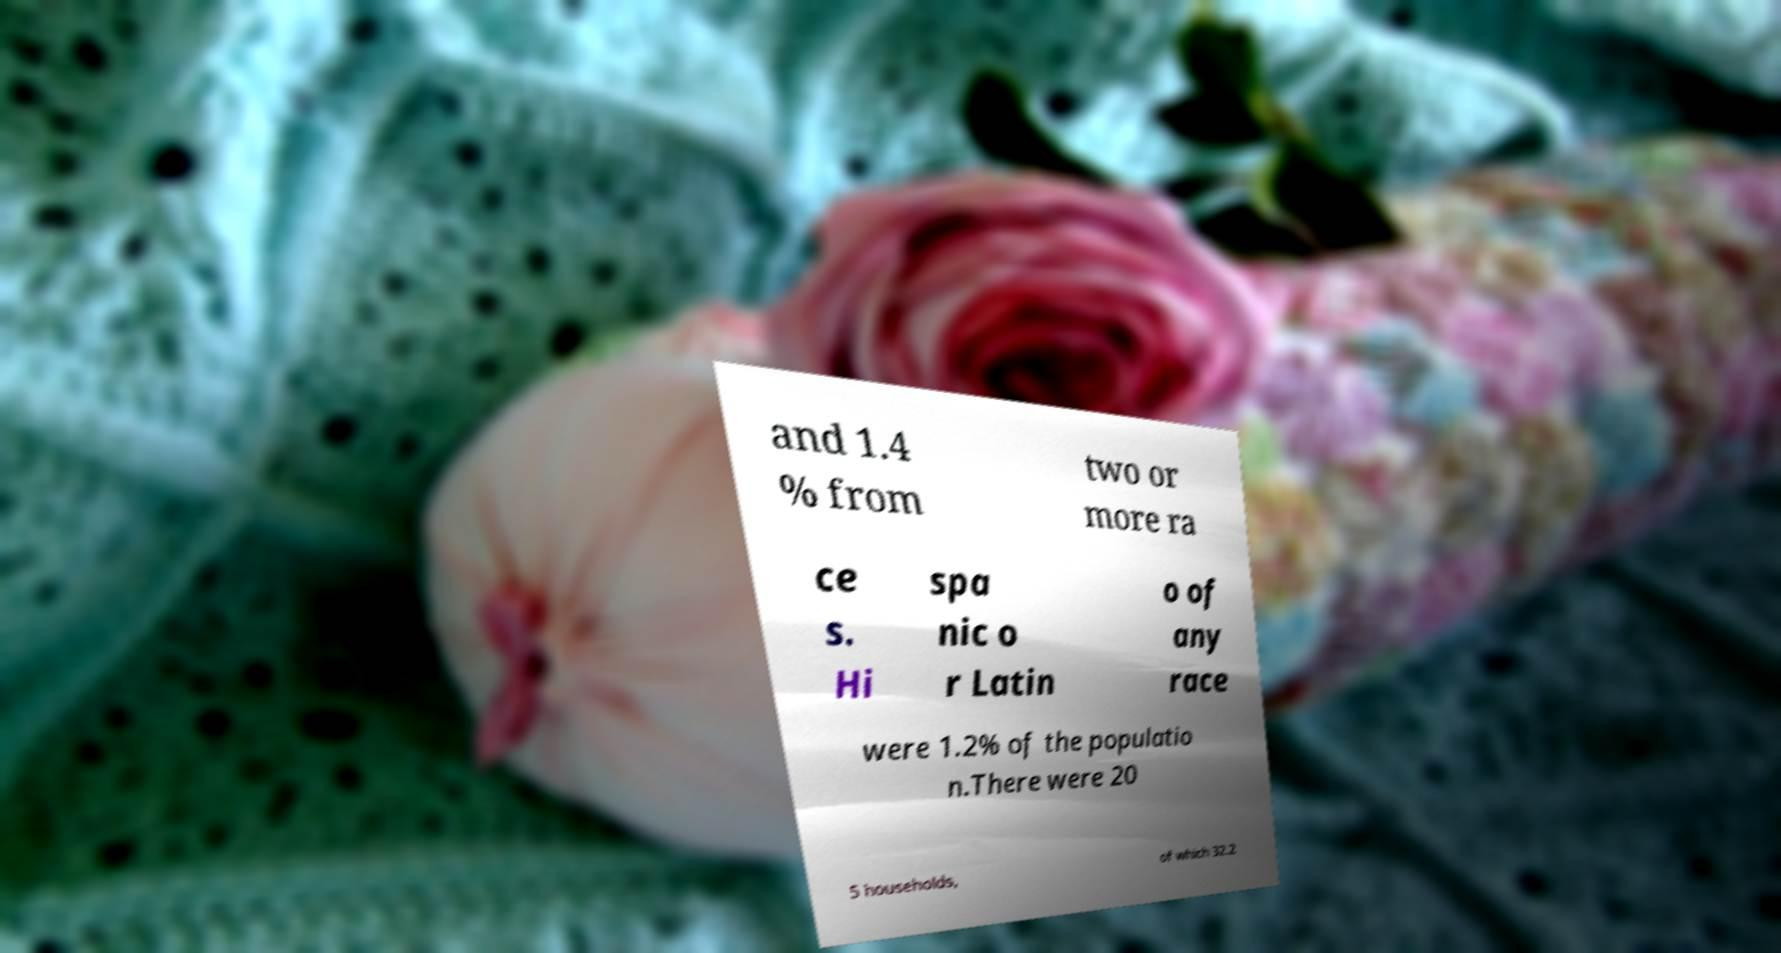Can you read and provide the text displayed in the image?This photo seems to have some interesting text. Can you extract and type it out for me? and 1.4 % from two or more ra ce s. Hi spa nic o r Latin o of any race were 1.2% of the populatio n.There were 20 5 households, of which 32.2 